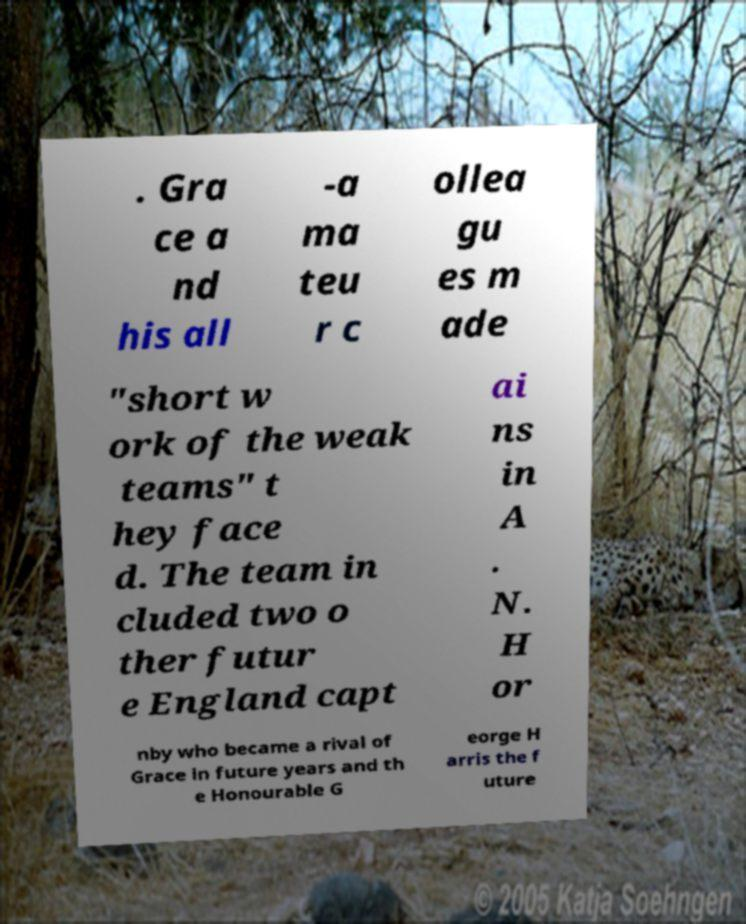For documentation purposes, I need the text within this image transcribed. Could you provide that? . Gra ce a nd his all -a ma teu r c ollea gu es m ade "short w ork of the weak teams" t hey face d. The team in cluded two o ther futur e England capt ai ns in A . N. H or nby who became a rival of Grace in future years and th e Honourable G eorge H arris the f uture 